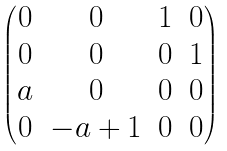Convert formula to latex. <formula><loc_0><loc_0><loc_500><loc_500>\begin{pmatrix} 0 & 0 & 1 & 0 \\ 0 & 0 & 0 & 1 \\ a & 0 & 0 & 0 \\ 0 & - a + 1 & 0 & 0 \end{pmatrix}</formula> 